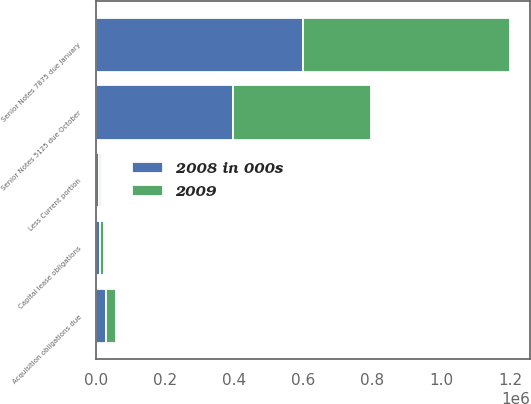Convert chart to OTSL. <chart><loc_0><loc_0><loc_500><loc_500><stacked_bar_chart><ecel><fcel>Senior Notes 7875 due January<fcel>Senior Notes 5125 due October<fcel>Acquisition obligations due<fcel>Capital lease obligations<fcel>Less Current portion<nl><fcel>2008 in 000s<fcel>599539<fcel>398706<fcel>30658<fcel>12001<fcel>8782<nl><fcel>2009<fcel>599414<fcel>398471<fcel>28398<fcel>12514<fcel>7286<nl></chart> 